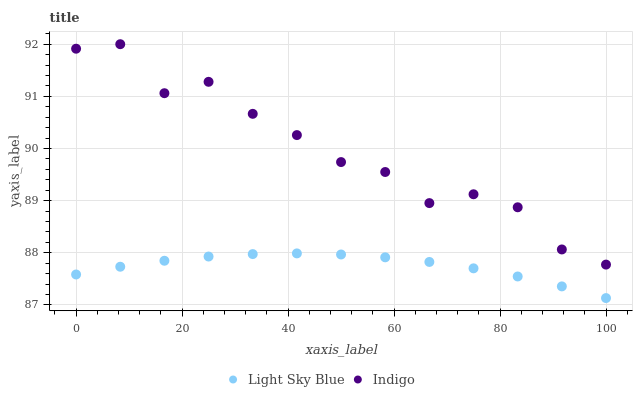Does Light Sky Blue have the minimum area under the curve?
Answer yes or no. Yes. Does Indigo have the maximum area under the curve?
Answer yes or no. Yes. Does Indigo have the minimum area under the curve?
Answer yes or no. No. Is Light Sky Blue the smoothest?
Answer yes or no. Yes. Is Indigo the roughest?
Answer yes or no. Yes. Is Indigo the smoothest?
Answer yes or no. No. Does Light Sky Blue have the lowest value?
Answer yes or no. Yes. Does Indigo have the lowest value?
Answer yes or no. No. Does Indigo have the highest value?
Answer yes or no. Yes. Is Light Sky Blue less than Indigo?
Answer yes or no. Yes. Is Indigo greater than Light Sky Blue?
Answer yes or no. Yes. Does Light Sky Blue intersect Indigo?
Answer yes or no. No. 